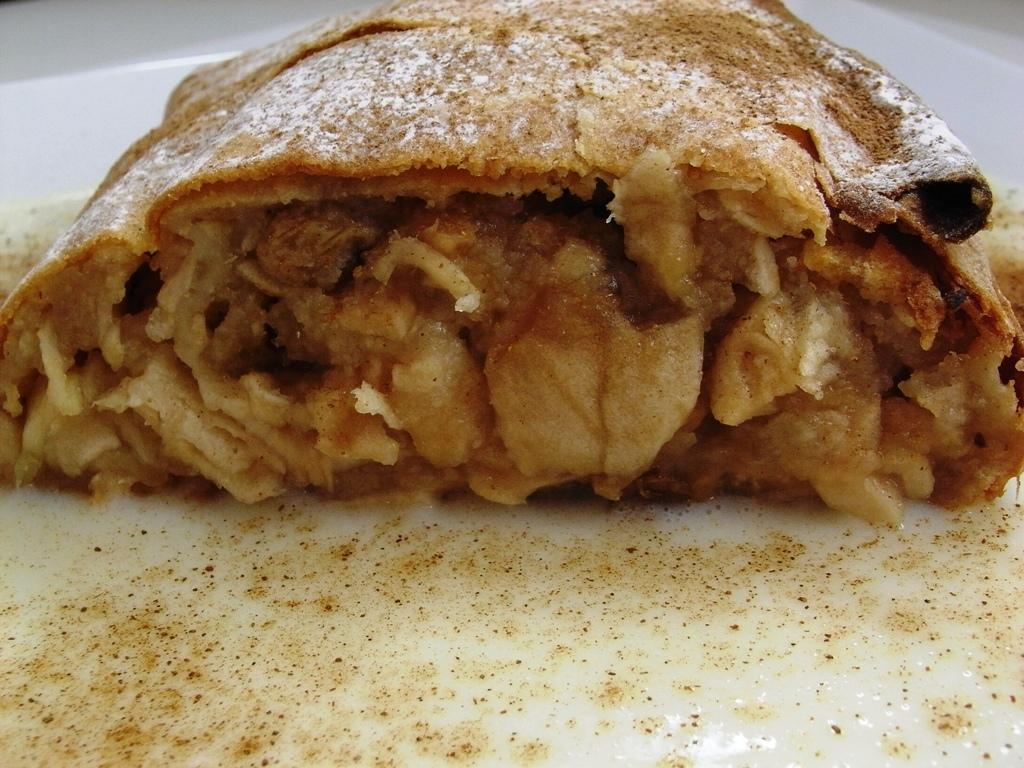What object is present on the plate in the image? The white plate contains an edible. What is the color of the plate in the image? The plate in the image is white. What can be inferred about the background of the image? The background of the image is white in color. How many boys are present in the image? There is no reference to any boys in the image, so it cannot be determined how many might be present. What type of humor can be seen in the image? There is no humor present in the image, as it features a white plate with an edible and a white background. 